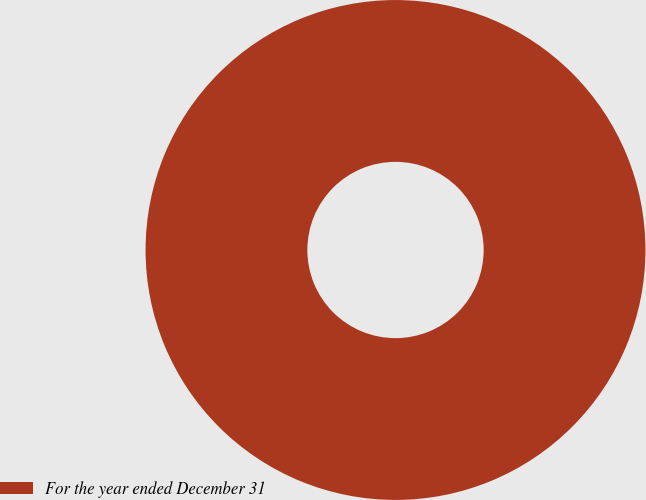<chart> <loc_0><loc_0><loc_500><loc_500><pie_chart><fcel>For the year ended December 31<nl><fcel>100.0%<nl></chart> 